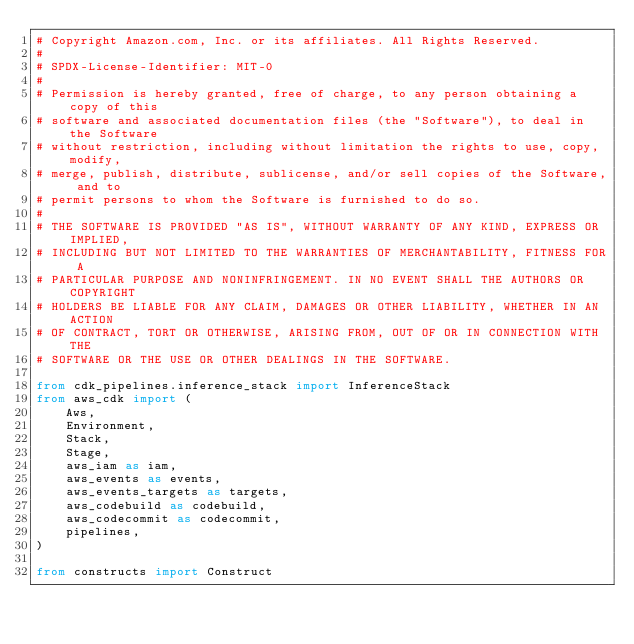<code> <loc_0><loc_0><loc_500><loc_500><_Python_># Copyright Amazon.com, Inc. or its affiliates. All Rights Reserved.
#
# SPDX-License-Identifier: MIT-0
#
# Permission is hereby granted, free of charge, to any person obtaining a copy of this
# software and associated documentation files (the "Software"), to deal in the Software
# without restriction, including without limitation the rights to use, copy, modify,
# merge, publish, distribute, sublicense, and/or sell copies of the Software, and to
# permit persons to whom the Software is furnished to do so.
#
# THE SOFTWARE IS PROVIDED "AS IS", WITHOUT WARRANTY OF ANY KIND, EXPRESS OR IMPLIED,
# INCLUDING BUT NOT LIMITED TO THE WARRANTIES OF MERCHANTABILITY, FITNESS FOR A
# PARTICULAR PURPOSE AND NONINFRINGEMENT. IN NO EVENT SHALL THE AUTHORS OR COPYRIGHT
# HOLDERS BE LIABLE FOR ANY CLAIM, DAMAGES OR OTHER LIABILITY, WHETHER IN AN ACTION
# OF CONTRACT, TORT OR OTHERWISE, ARISING FROM, OUT OF OR IN CONNECTION WITH THE
# SOFTWARE OR THE USE OR OTHER DEALINGS IN THE SOFTWARE.

from cdk_pipelines.inference_stack import InferenceStack
from aws_cdk import (
    Aws,
    Environment,
    Stack,
    Stage,
    aws_iam as iam,
    aws_events as events,
    aws_events_targets as targets,
    aws_codebuild as codebuild,
    aws_codecommit as codecommit,
    pipelines,
)

from constructs import Construct
</code> 